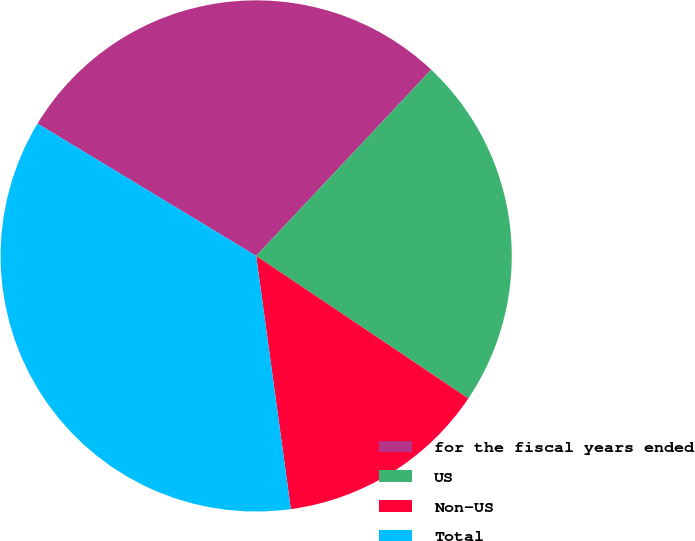<chart> <loc_0><loc_0><loc_500><loc_500><pie_chart><fcel>for the fiscal years ended<fcel>US<fcel>Non-US<fcel>Total<nl><fcel>28.35%<fcel>22.41%<fcel>13.42%<fcel>35.83%<nl></chart> 